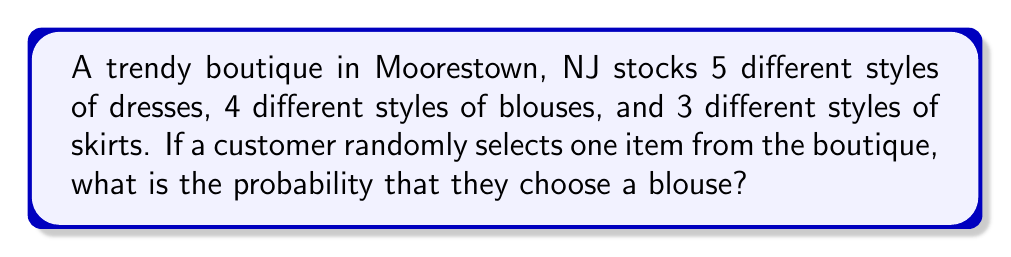Can you solve this math problem? Let's approach this step-by-step:

1) First, we need to determine the total number of clothing items in the boutique:
   - Dresses: 5
   - Blouses: 4
   - Skirts: 3

2) The total number of items is:
   $$ 5 + 4 + 3 = 12 $$

3) Now, we need to determine how many favorable outcomes there are. In this case, we want to know the probability of selecting a blouse. There are 4 blouses.

4) The probability of an event is calculated by dividing the number of favorable outcomes by the total number of possible outcomes:

   $$ P(\text{blouse}) = \frac{\text{number of blouses}}{\text{total number of items}} $$

5) Substituting our values:

   $$ P(\text{blouse}) = \frac{4}{12} $$

6) This fraction can be reduced:

   $$ P(\text{blouse}) = \frac{1}{3} $$

Therefore, the probability of randomly selecting a blouse is $\frac{1}{3}$ or approximately 0.333 or 33.3%.
Answer: $\frac{1}{3}$ 